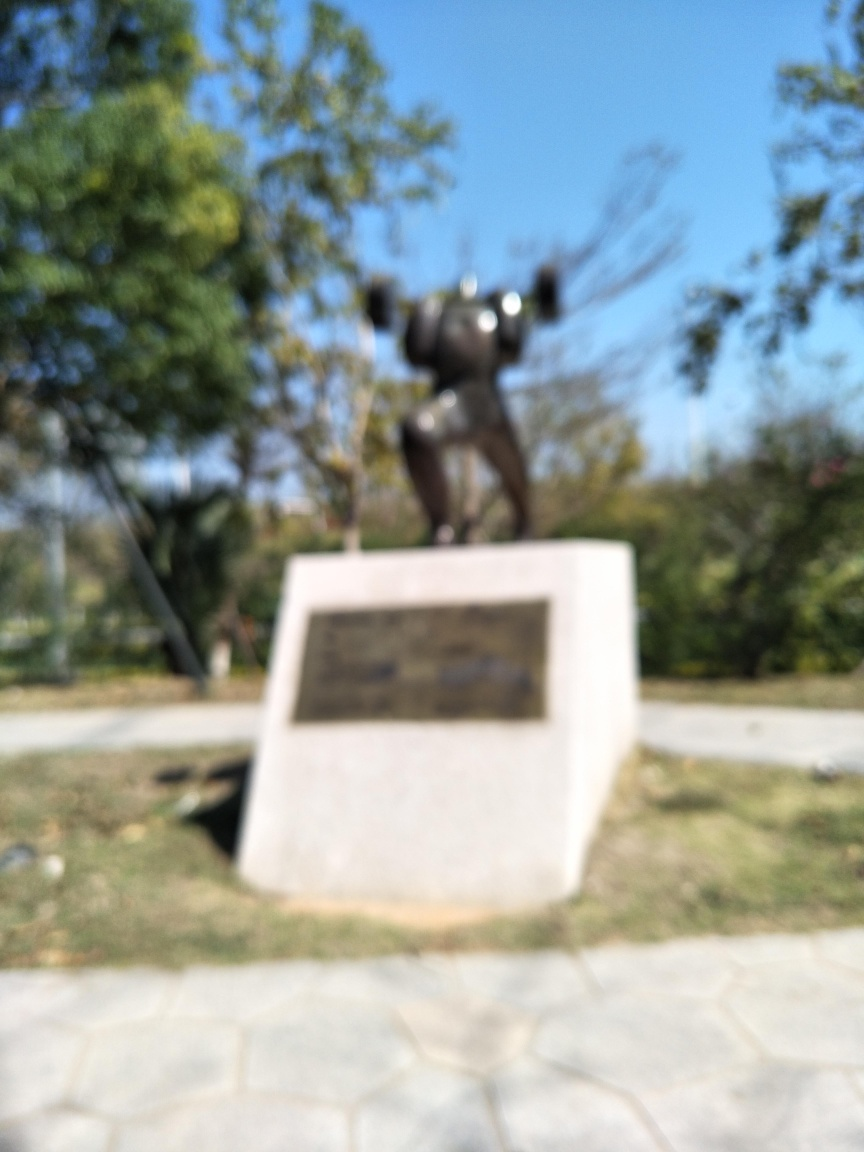Does the quality of this image look very poor? Based on the evaluation of the image, option B is correct — the quality of the image does indeed appear to be very poor. The primary reason for this assessment is the noticeable blurriness, which obscures details such as the text on the plaque and the features of the statue. This lack of sharpness suggests either motion blur due to camera movement, a focus issue, or a lower resolution capture device was used. 